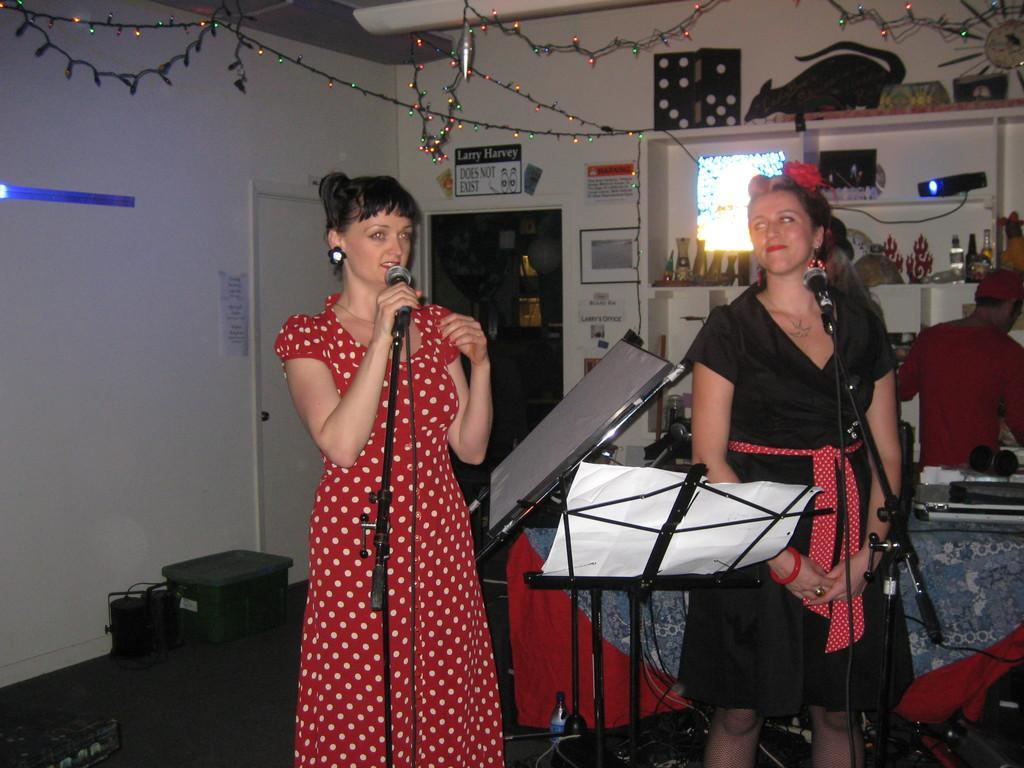Please provide a concise description of this image. In this picture there is a woman who is wearing red dress She is holding a mic and singing. Beside her we can see the board and paper. On the right there is another woman who is wearing black dress. She is standing near to the mic. At the back we can see the table, beside the table there is a man who is wearing red dress. He is standing near to the shelf. On the shelf we can see bottles, stickers, projector machine and other objects. in the background we can see the door, frames and other objects. In bottom left corner we can see the black box near to the wall. At the top we can see the light. 